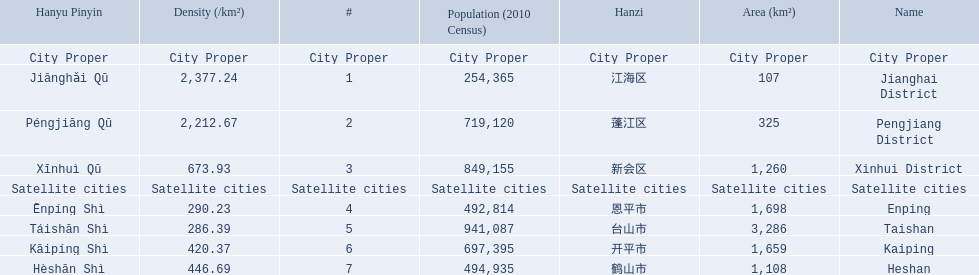What are the satellite cities of jiangmen? Enping, Taishan, Kaiping, Heshan. Of these cities, which has the highest density? Taishan. 